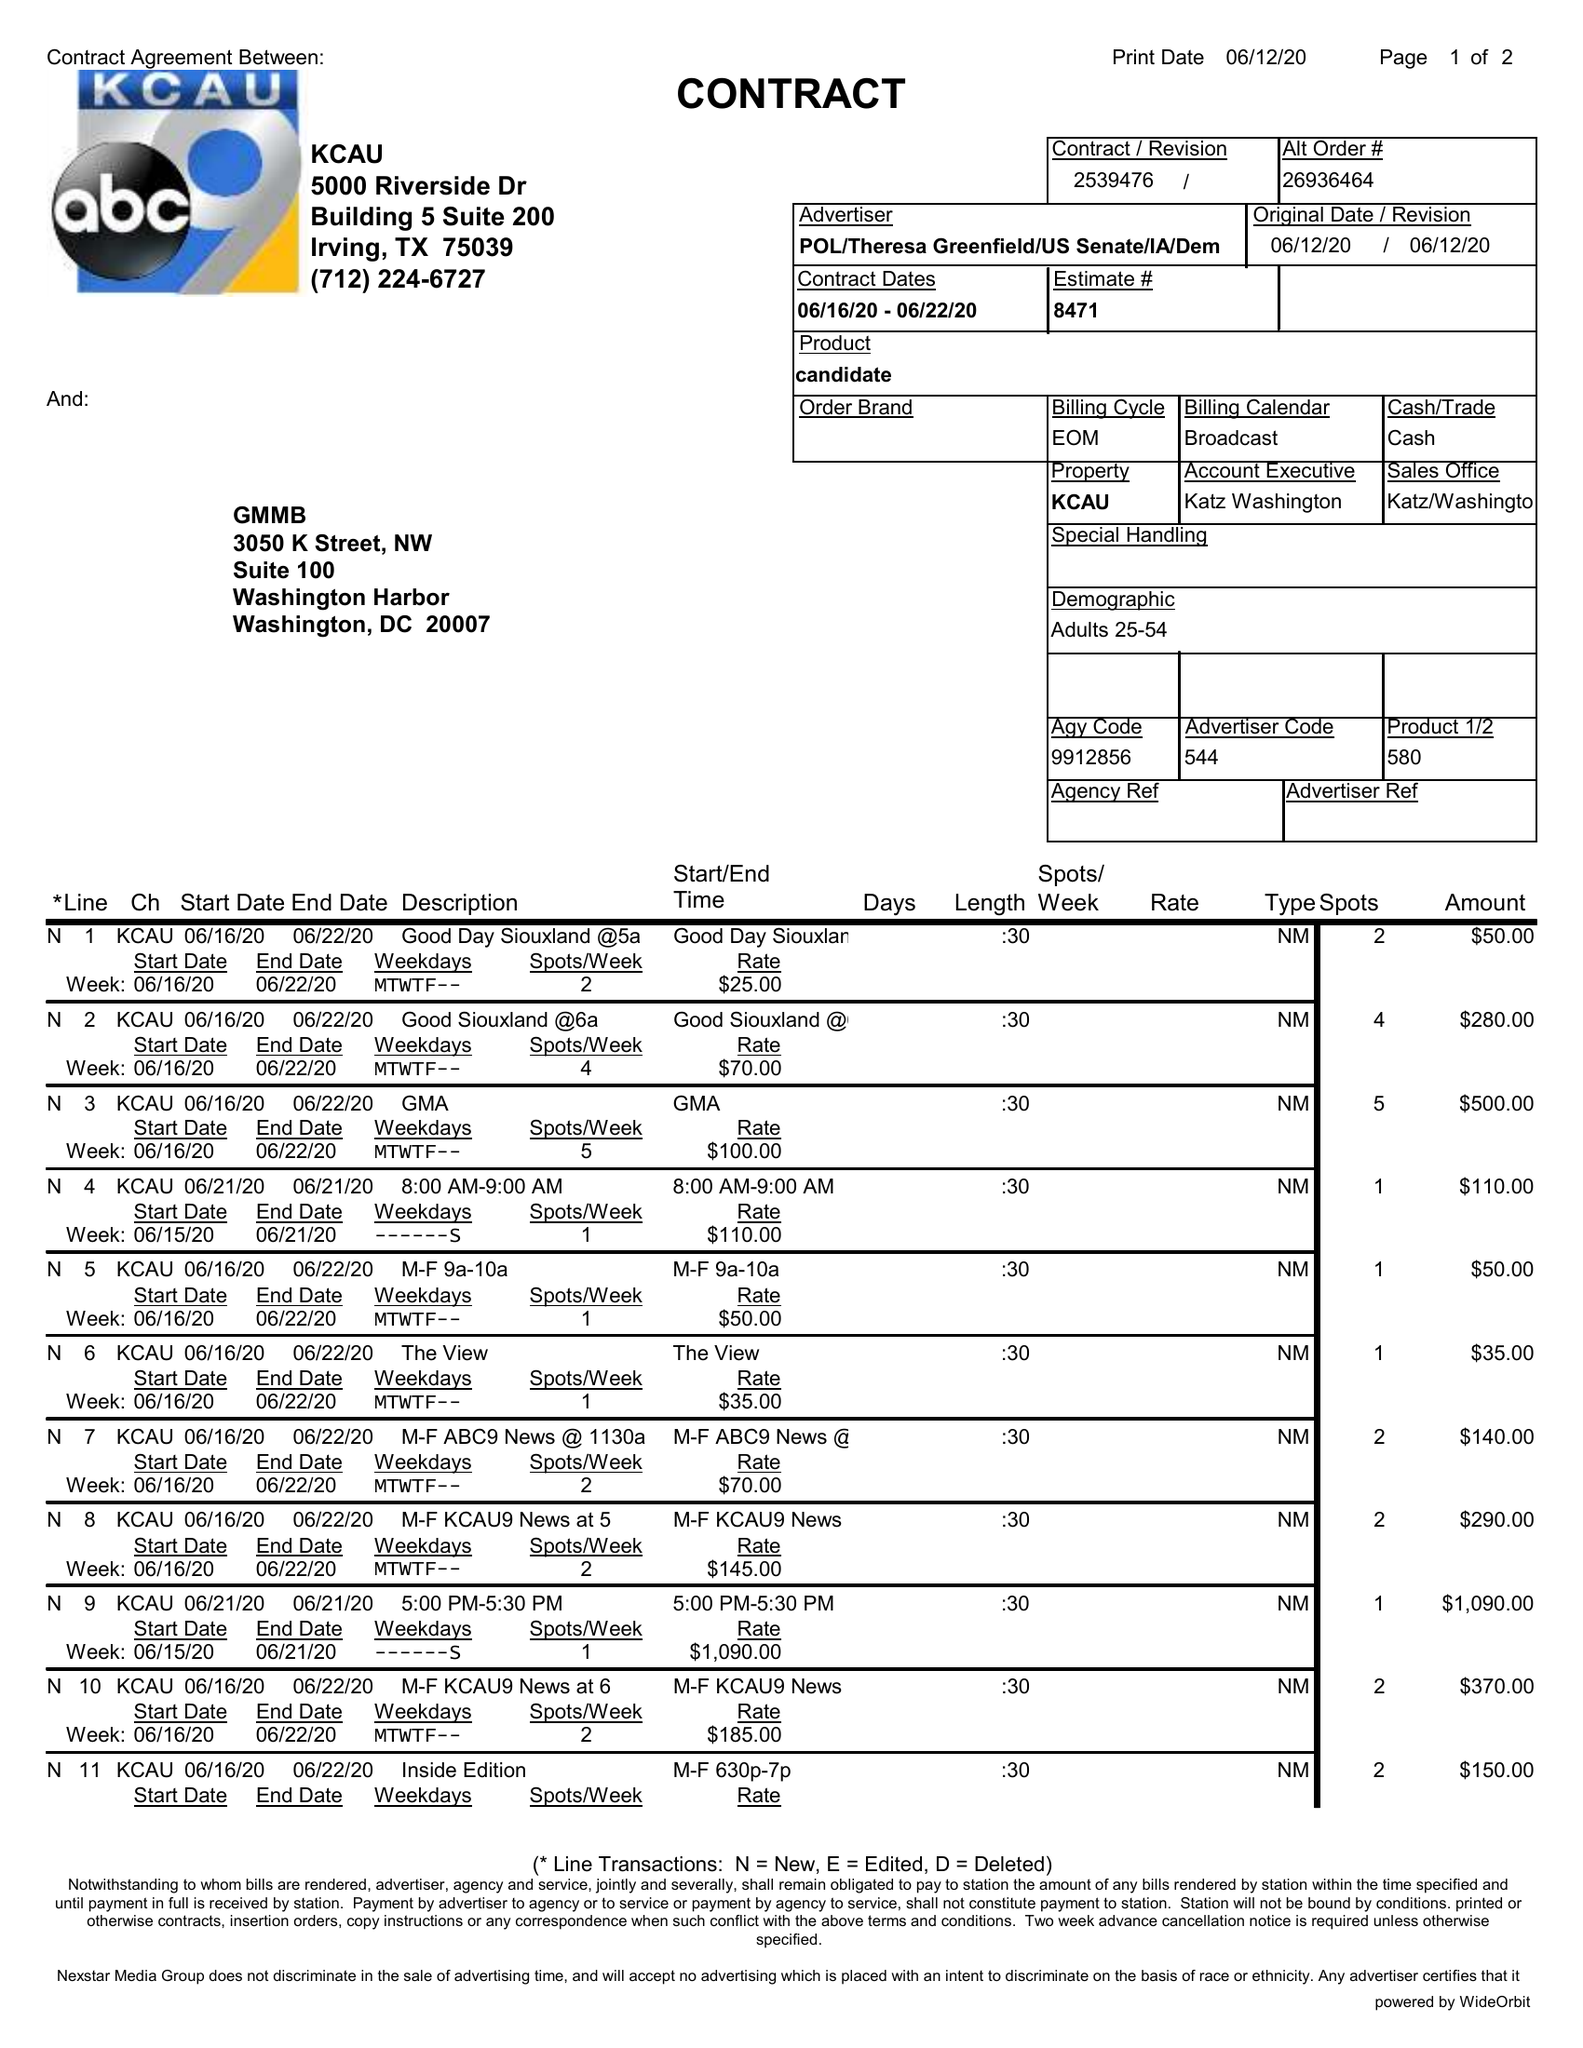What is the value for the advertiser?
Answer the question using a single word or phrase. POL/THERESAGREENFIELD/USSENATE/IA/DEM 